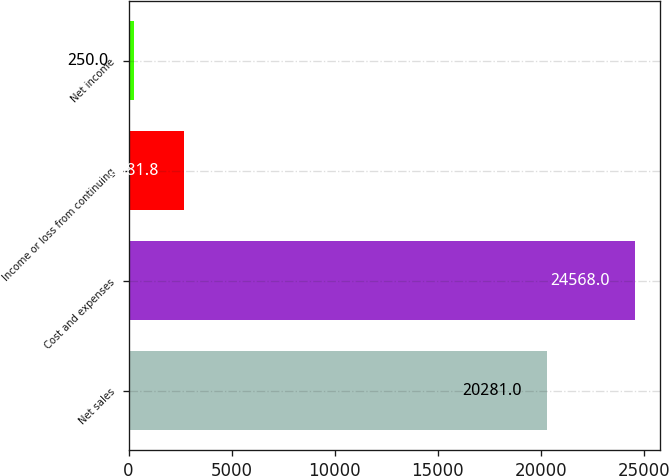Convert chart. <chart><loc_0><loc_0><loc_500><loc_500><bar_chart><fcel>Net sales<fcel>Cost and expenses<fcel>Income or loss from continuing<fcel>Net income<nl><fcel>20281<fcel>24568<fcel>2681.8<fcel>250<nl></chart> 